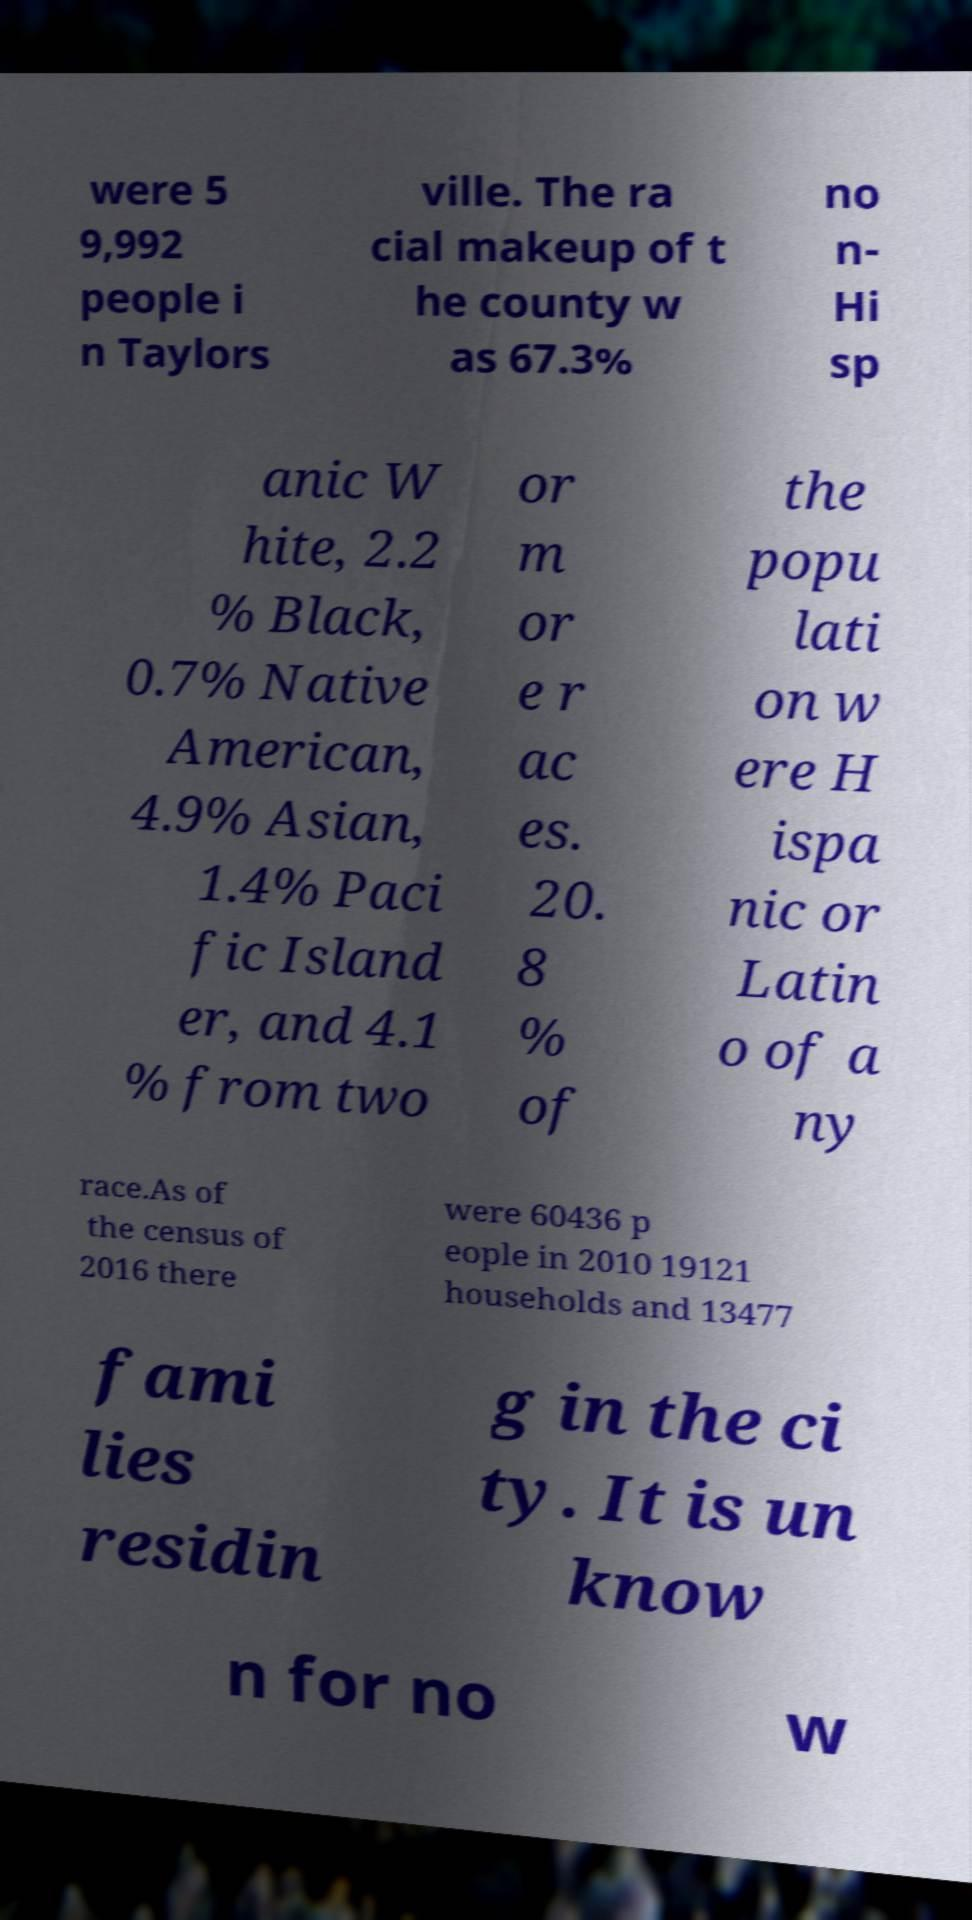Can you read and provide the text displayed in the image?This photo seems to have some interesting text. Can you extract and type it out for me? were 5 9,992 people i n Taylors ville. The ra cial makeup of t he county w as 67.3% no n- Hi sp anic W hite, 2.2 % Black, 0.7% Native American, 4.9% Asian, 1.4% Paci fic Island er, and 4.1 % from two or m or e r ac es. 20. 8 % of the popu lati on w ere H ispa nic or Latin o of a ny race.As of the census of 2016 there were 60436 p eople in 2010 19121 households and 13477 fami lies residin g in the ci ty. It is un know n for no w 